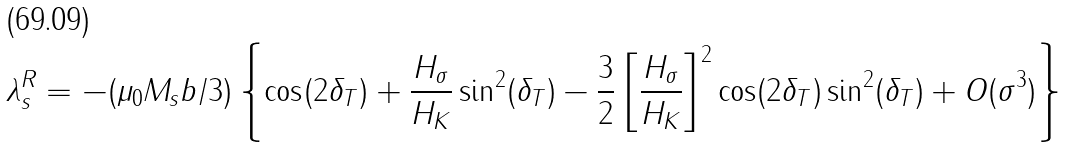Convert formula to latex. <formula><loc_0><loc_0><loc_500><loc_500>\lambda _ { s } ^ { R } = - ( \mu _ { 0 } M _ { s } b / 3 ) \left \{ \cos ( 2 \delta _ { T } ) + \frac { H _ { \sigma } } { H _ { K } } \sin ^ { 2 } ( \delta _ { T } ) - \frac { 3 } { 2 } \left [ \frac { H _ { \sigma } } { H _ { K } } \right ] ^ { 2 } \cos ( 2 \delta _ { T } ) \sin ^ { 2 } ( \delta _ { T } ) + O ( { \sigma } ^ { 3 } ) \right \}</formula> 